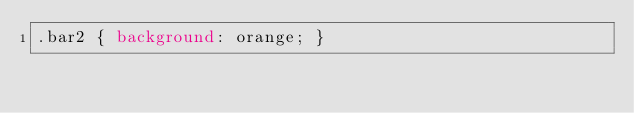<code> <loc_0><loc_0><loc_500><loc_500><_CSS_>.bar2 { background: orange; }
</code> 